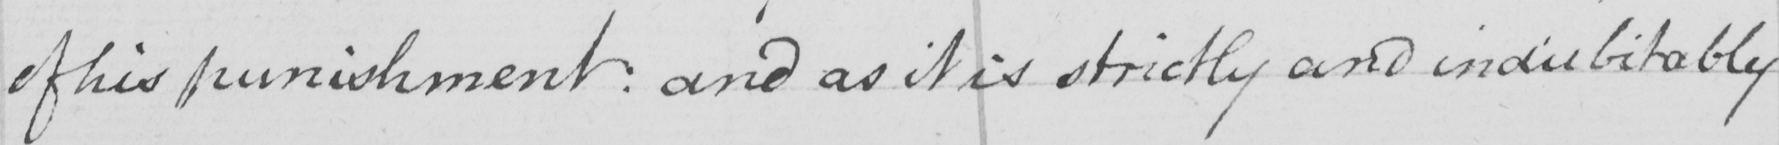Can you read and transcribe this handwriting? of his punishment  :  and as it is strictly and indubitably 